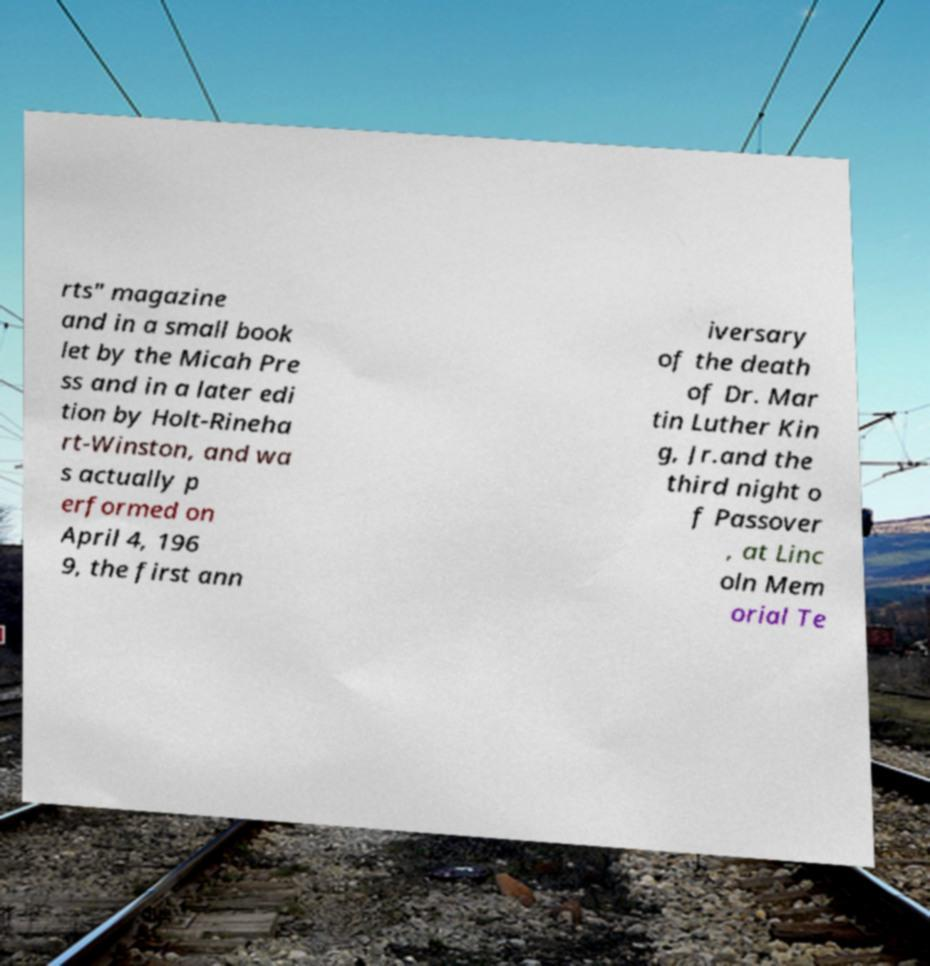Could you extract and type out the text from this image? rts" magazine and in a small book let by the Micah Pre ss and in a later edi tion by Holt-Rineha rt-Winston, and wa s actually p erformed on April 4, 196 9, the first ann iversary of the death of Dr. Mar tin Luther Kin g, Jr.and the third night o f Passover , at Linc oln Mem orial Te 